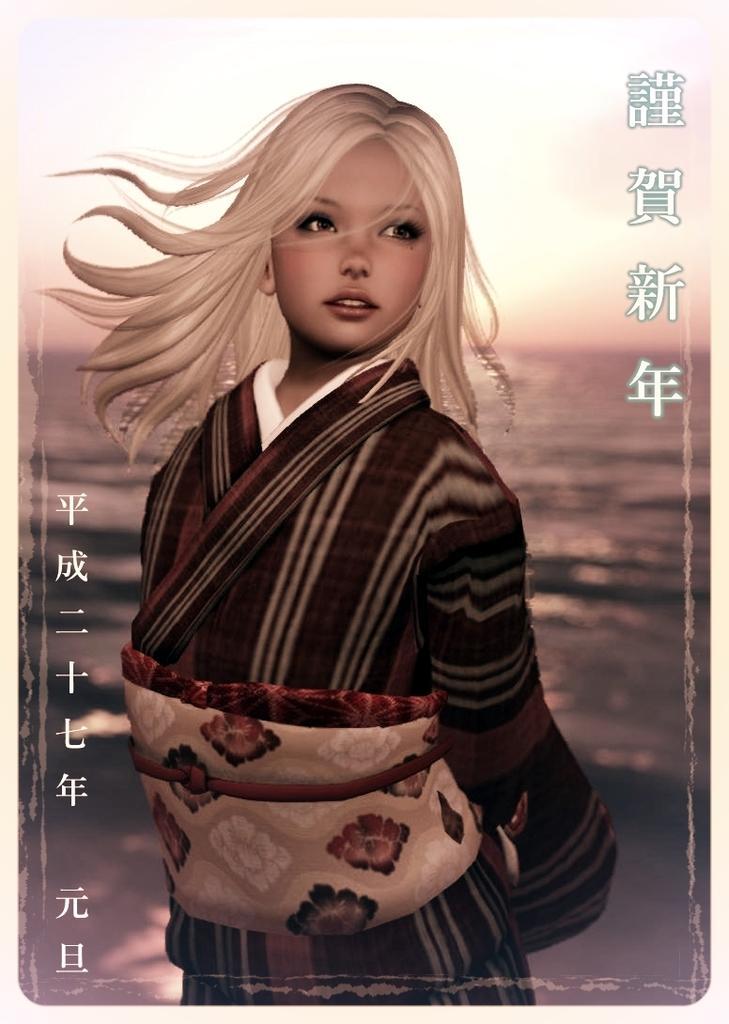In one or two sentences, can you explain what this image depicts? It is an animated picture, this is girl she wore dress behind her it's water. 